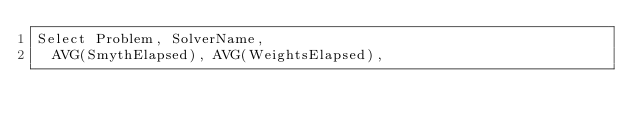<code> <loc_0><loc_0><loc_500><loc_500><_SQL_>Select Problem, SolverName, 
  AVG(SmythElapsed), AVG(WeightsElapsed),</code> 